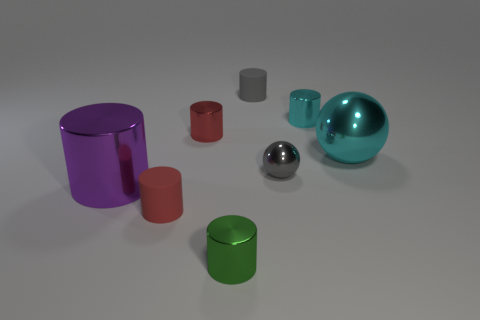Subtract all red cylinders. How many cylinders are left? 4 Subtract all tiny red cylinders. How many cylinders are left? 4 Subtract all purple cylinders. Subtract all yellow cubes. How many cylinders are left? 5 Add 2 small green blocks. How many objects exist? 10 Subtract all balls. How many objects are left? 6 Subtract 0 blue cylinders. How many objects are left? 8 Subtract all big purple cubes. Subtract all small gray things. How many objects are left? 6 Add 4 rubber objects. How many rubber objects are left? 6 Add 6 large rubber cylinders. How many large rubber cylinders exist? 6 